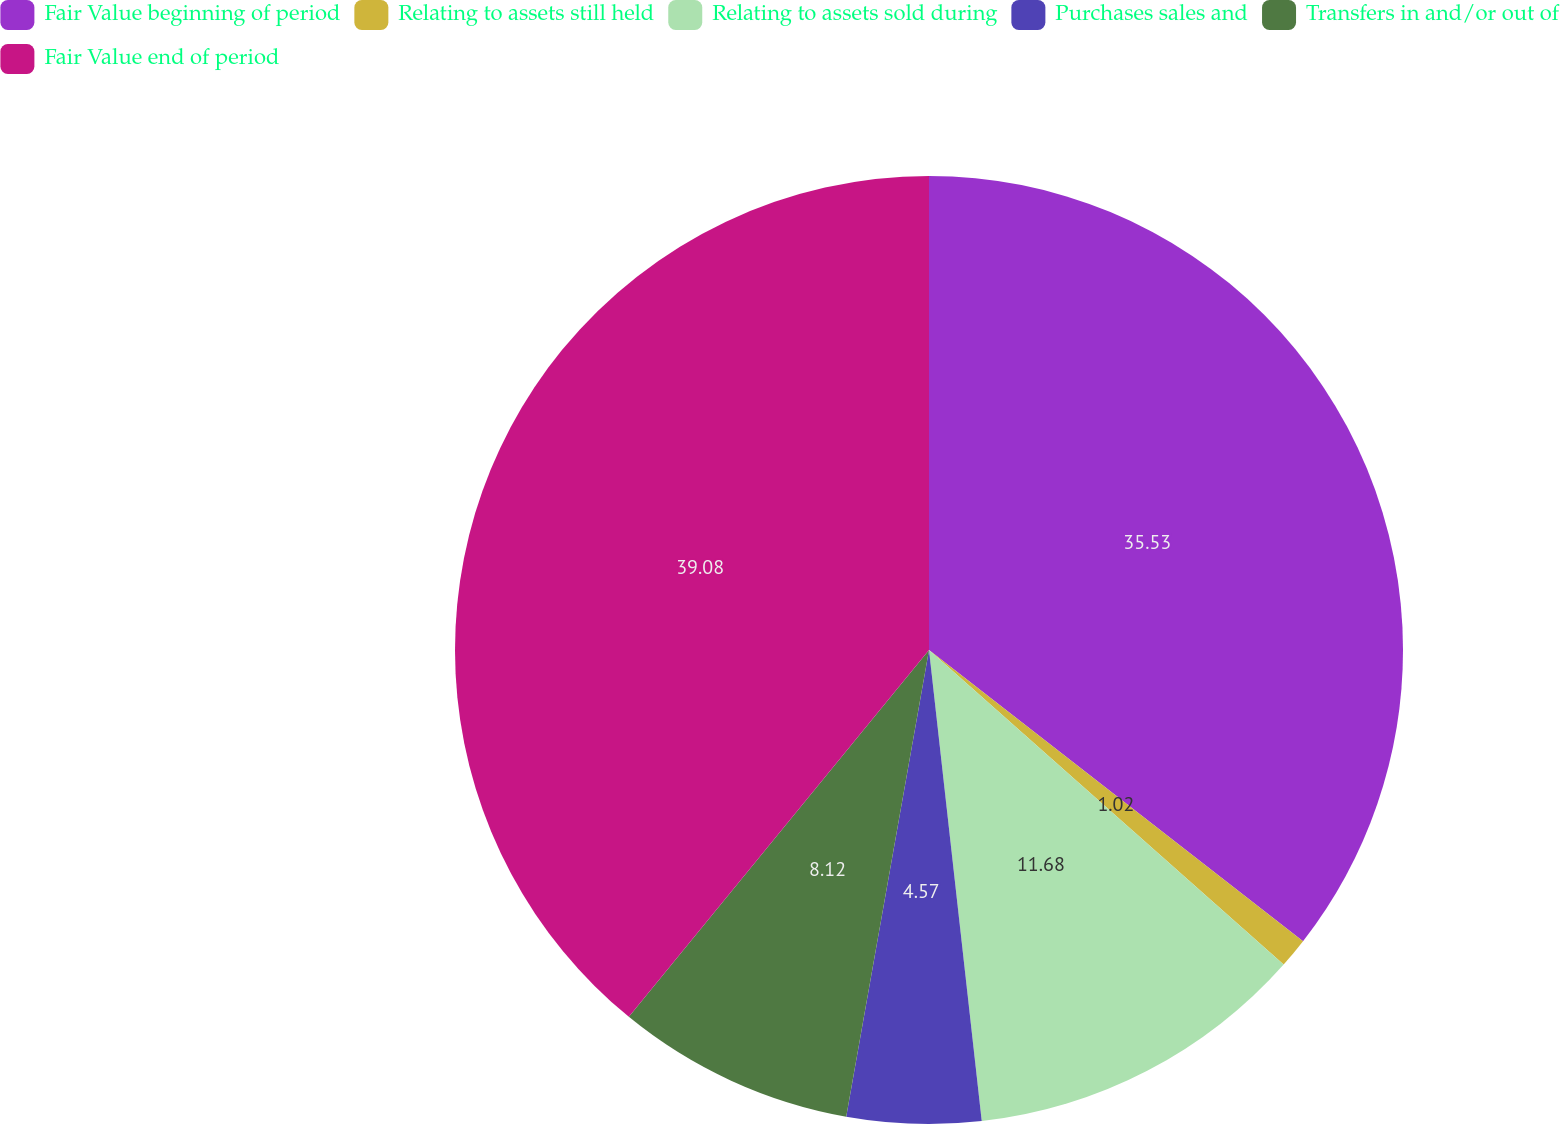<chart> <loc_0><loc_0><loc_500><loc_500><pie_chart><fcel>Fair Value beginning of period<fcel>Relating to assets still held<fcel>Relating to assets sold during<fcel>Purchases sales and<fcel>Transfers in and/or out of<fcel>Fair Value end of period<nl><fcel>35.53%<fcel>1.02%<fcel>11.68%<fcel>4.57%<fcel>8.12%<fcel>39.09%<nl></chart> 